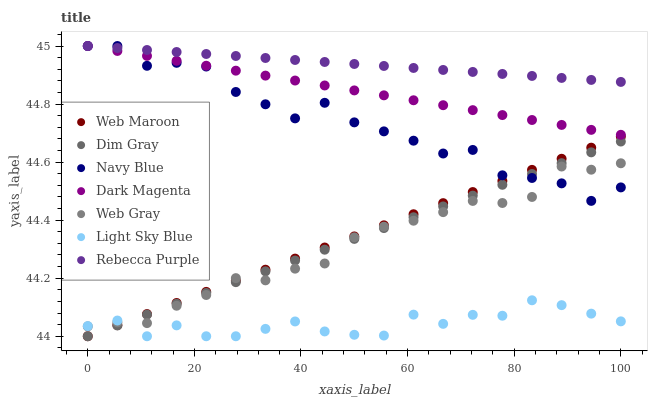Does Light Sky Blue have the minimum area under the curve?
Answer yes or no. Yes. Does Rebecca Purple have the maximum area under the curve?
Answer yes or no. Yes. Does Dark Magenta have the minimum area under the curve?
Answer yes or no. No. Does Dark Magenta have the maximum area under the curve?
Answer yes or no. No. Is Web Maroon the smoothest?
Answer yes or no. Yes. Is Navy Blue the roughest?
Answer yes or no. Yes. Is Dark Magenta the smoothest?
Answer yes or no. No. Is Dark Magenta the roughest?
Answer yes or no. No. Does Web Maroon have the lowest value?
Answer yes or no. Yes. Does Dark Magenta have the lowest value?
Answer yes or no. No. Does Rebecca Purple have the highest value?
Answer yes or no. Yes. Does Web Maroon have the highest value?
Answer yes or no. No. Is Dim Gray less than Rebecca Purple?
Answer yes or no. Yes. Is Dark Magenta greater than Light Sky Blue?
Answer yes or no. Yes. Does Light Sky Blue intersect Web Maroon?
Answer yes or no. Yes. Is Light Sky Blue less than Web Maroon?
Answer yes or no. No. Is Light Sky Blue greater than Web Maroon?
Answer yes or no. No. Does Dim Gray intersect Rebecca Purple?
Answer yes or no. No. 